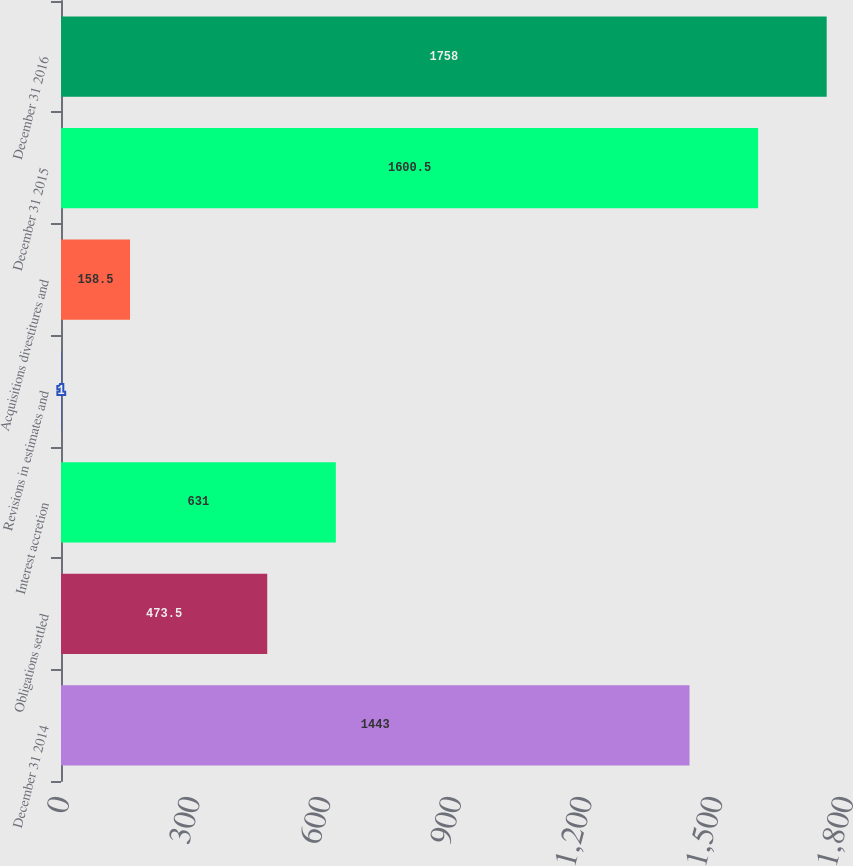<chart> <loc_0><loc_0><loc_500><loc_500><bar_chart><fcel>December 31 2014<fcel>Obligations settled<fcel>Interest accretion<fcel>Revisions in estimates and<fcel>Acquisitions divestitures and<fcel>December 31 2015<fcel>December 31 2016<nl><fcel>1443<fcel>473.5<fcel>631<fcel>1<fcel>158.5<fcel>1600.5<fcel>1758<nl></chart> 